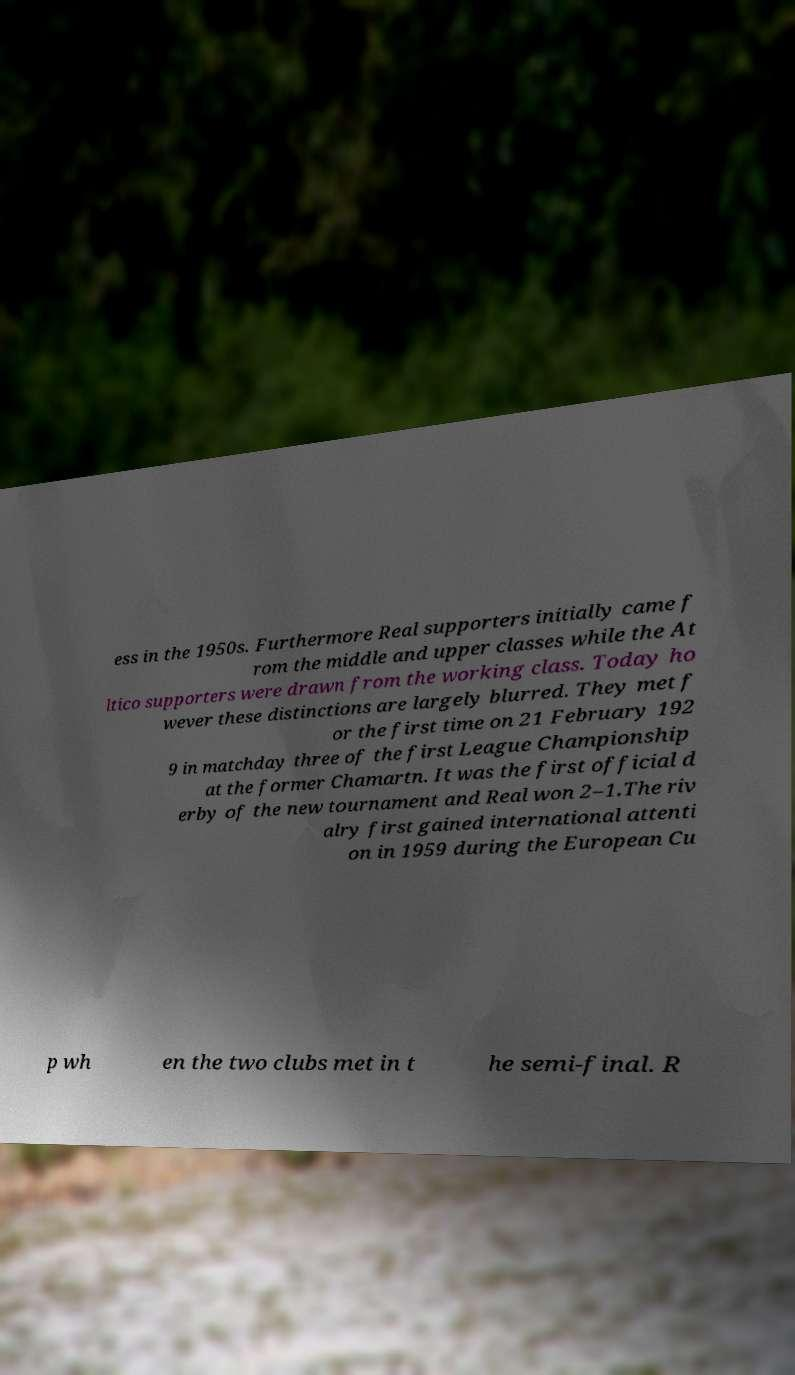Can you read and provide the text displayed in the image?This photo seems to have some interesting text. Can you extract and type it out for me? ess in the 1950s. Furthermore Real supporters initially came f rom the middle and upper classes while the At ltico supporters were drawn from the working class. Today ho wever these distinctions are largely blurred. They met f or the first time on 21 February 192 9 in matchday three of the first League Championship at the former Chamartn. It was the first official d erby of the new tournament and Real won 2–1.The riv alry first gained international attenti on in 1959 during the European Cu p wh en the two clubs met in t he semi-final. R 